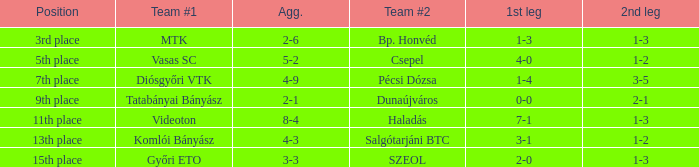What is the team #1 with an 11th place position? Videoton. Would you mind parsing the complete table? {'header': ['Position', 'Team #1', 'Agg.', 'Team #2', '1st leg', '2nd leg'], 'rows': [['3rd place', 'MTK', '2-6', 'Bp. Honvéd', '1-3', '1-3'], ['5th place', 'Vasas SC', '5-2', 'Csepel', '4-0', '1-2'], ['7th place', 'Diósgyőri VTK', '4-9', 'Pécsi Dózsa', '1-4', '3-5'], ['9th place', 'Tatabányai Bányász', '2-1', 'Dunaújváros', '0-0', '2-1'], ['11th place', 'Videoton', '8-4', 'Haladás', '7-1', '1-3'], ['13th place', 'Komlói Bányász', '4-3', 'Salgótarjáni BTC', '3-1', '1-2'], ['15th place', 'Győri ETO', '3-3', 'SZEOL', '2-0', '1-3']]} 